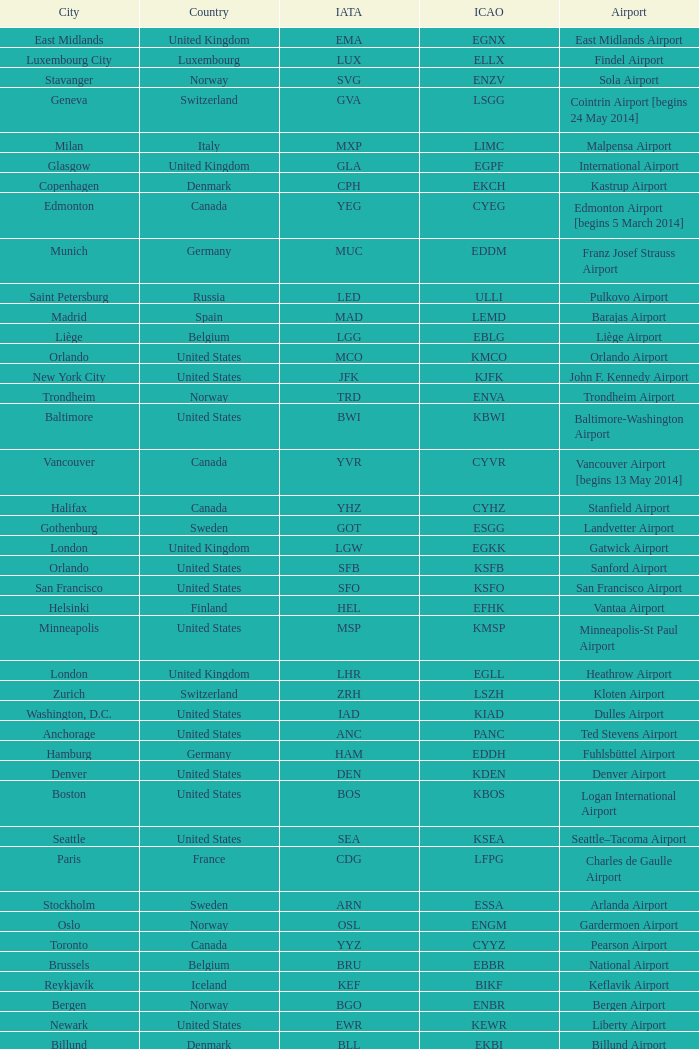What is the Airport with a ICAO of EDDH? Fuhlsbüttel Airport. 